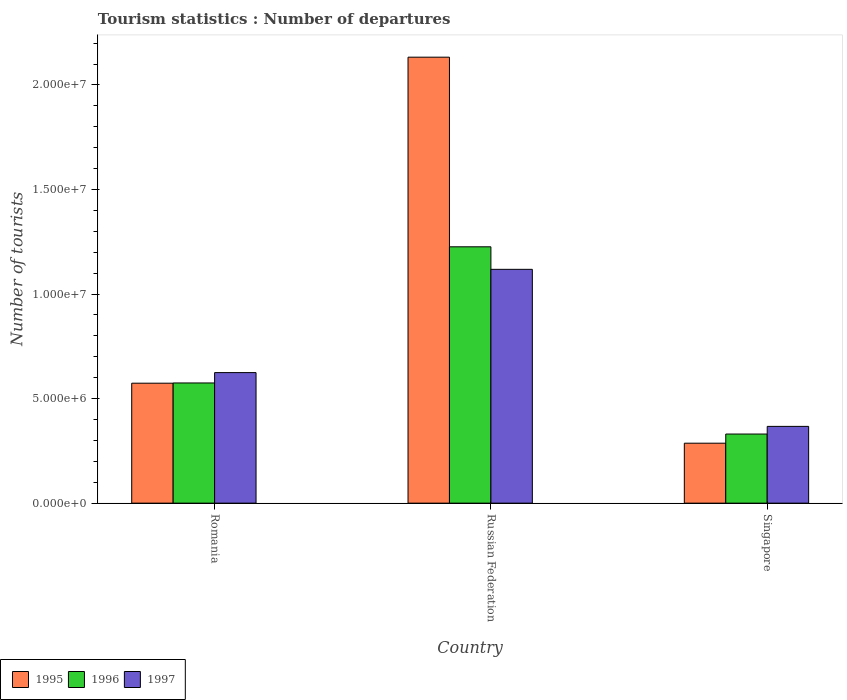Are the number of bars per tick equal to the number of legend labels?
Your response must be concise. Yes. How many bars are there on the 2nd tick from the left?
Keep it short and to the point. 3. What is the label of the 1st group of bars from the left?
Keep it short and to the point. Romania. In how many cases, is the number of bars for a given country not equal to the number of legend labels?
Make the answer very short. 0. What is the number of tourist departures in 1995 in Russian Federation?
Make the answer very short. 2.13e+07. Across all countries, what is the maximum number of tourist departures in 1997?
Offer a very short reply. 1.12e+07. Across all countries, what is the minimum number of tourist departures in 1997?
Give a very brief answer. 3.67e+06. In which country was the number of tourist departures in 1997 maximum?
Give a very brief answer. Russian Federation. In which country was the number of tourist departures in 1996 minimum?
Provide a succinct answer. Singapore. What is the total number of tourist departures in 1997 in the graph?
Make the answer very short. 2.11e+07. What is the difference between the number of tourist departures in 1997 in Romania and that in Singapore?
Give a very brief answer. 2.57e+06. What is the difference between the number of tourist departures in 1997 in Romania and the number of tourist departures in 1996 in Singapore?
Your response must be concise. 2.94e+06. What is the average number of tourist departures in 1996 per country?
Offer a very short reply. 7.10e+06. What is the difference between the number of tourist departures of/in 1996 and number of tourist departures of/in 1995 in Russian Federation?
Give a very brief answer. -9.07e+06. What is the ratio of the number of tourist departures in 1997 in Romania to that in Russian Federation?
Give a very brief answer. 0.56. What is the difference between the highest and the second highest number of tourist departures in 1997?
Make the answer very short. 4.94e+06. What is the difference between the highest and the lowest number of tourist departures in 1997?
Your response must be concise. 7.51e+06. In how many countries, is the number of tourist departures in 1997 greater than the average number of tourist departures in 1997 taken over all countries?
Offer a terse response. 1. Is the sum of the number of tourist departures in 1995 in Russian Federation and Singapore greater than the maximum number of tourist departures in 1997 across all countries?
Ensure brevity in your answer.  Yes. What does the 2nd bar from the right in Russian Federation represents?
Your answer should be very brief. 1996. What is the difference between two consecutive major ticks on the Y-axis?
Your response must be concise. 5.00e+06. Are the values on the major ticks of Y-axis written in scientific E-notation?
Provide a short and direct response. Yes. How many legend labels are there?
Keep it short and to the point. 3. What is the title of the graph?
Provide a succinct answer. Tourism statistics : Number of departures. What is the label or title of the Y-axis?
Provide a short and direct response. Number of tourists. What is the Number of tourists in 1995 in Romania?
Your response must be concise. 5.74e+06. What is the Number of tourists of 1996 in Romania?
Make the answer very short. 5.75e+06. What is the Number of tourists of 1997 in Romania?
Your answer should be compact. 6.24e+06. What is the Number of tourists of 1995 in Russian Federation?
Keep it short and to the point. 2.13e+07. What is the Number of tourists of 1996 in Russian Federation?
Offer a very short reply. 1.23e+07. What is the Number of tourists of 1997 in Russian Federation?
Your response must be concise. 1.12e+07. What is the Number of tourists of 1995 in Singapore?
Offer a very short reply. 2.87e+06. What is the Number of tourists of 1996 in Singapore?
Your response must be concise. 3.30e+06. What is the Number of tourists in 1997 in Singapore?
Your response must be concise. 3.67e+06. Across all countries, what is the maximum Number of tourists in 1995?
Provide a short and direct response. 2.13e+07. Across all countries, what is the maximum Number of tourists in 1996?
Offer a terse response. 1.23e+07. Across all countries, what is the maximum Number of tourists in 1997?
Ensure brevity in your answer.  1.12e+07. Across all countries, what is the minimum Number of tourists of 1995?
Ensure brevity in your answer.  2.87e+06. Across all countries, what is the minimum Number of tourists in 1996?
Give a very brief answer. 3.30e+06. Across all countries, what is the minimum Number of tourists of 1997?
Make the answer very short. 3.67e+06. What is the total Number of tourists of 1995 in the graph?
Offer a very short reply. 2.99e+07. What is the total Number of tourists in 1996 in the graph?
Your answer should be very brief. 2.13e+07. What is the total Number of tourists in 1997 in the graph?
Give a very brief answer. 2.11e+07. What is the difference between the Number of tourists in 1995 in Romania and that in Russian Federation?
Your answer should be very brief. -1.56e+07. What is the difference between the Number of tourists of 1996 in Romania and that in Russian Federation?
Provide a short and direct response. -6.51e+06. What is the difference between the Number of tourists in 1997 in Romania and that in Russian Federation?
Ensure brevity in your answer.  -4.94e+06. What is the difference between the Number of tourists in 1995 in Romania and that in Singapore?
Provide a succinct answer. 2.87e+06. What is the difference between the Number of tourists in 1996 in Romania and that in Singapore?
Make the answer very short. 2.44e+06. What is the difference between the Number of tourists of 1997 in Romania and that in Singapore?
Keep it short and to the point. 2.57e+06. What is the difference between the Number of tourists of 1995 in Russian Federation and that in Singapore?
Give a very brief answer. 1.85e+07. What is the difference between the Number of tourists in 1996 in Russian Federation and that in Singapore?
Make the answer very short. 8.96e+06. What is the difference between the Number of tourists of 1997 in Russian Federation and that in Singapore?
Make the answer very short. 7.51e+06. What is the difference between the Number of tourists in 1995 in Romania and the Number of tourists in 1996 in Russian Federation?
Provide a short and direct response. -6.52e+06. What is the difference between the Number of tourists in 1995 in Romania and the Number of tourists in 1997 in Russian Federation?
Your response must be concise. -5.44e+06. What is the difference between the Number of tourists of 1996 in Romania and the Number of tourists of 1997 in Russian Federation?
Offer a very short reply. -5.43e+06. What is the difference between the Number of tourists of 1995 in Romania and the Number of tourists of 1996 in Singapore?
Your answer should be compact. 2.43e+06. What is the difference between the Number of tourists of 1995 in Romania and the Number of tourists of 1997 in Singapore?
Provide a short and direct response. 2.07e+06. What is the difference between the Number of tourists in 1996 in Romania and the Number of tourists in 1997 in Singapore?
Your answer should be very brief. 2.08e+06. What is the difference between the Number of tourists of 1995 in Russian Federation and the Number of tourists of 1996 in Singapore?
Offer a very short reply. 1.80e+07. What is the difference between the Number of tourists of 1995 in Russian Federation and the Number of tourists of 1997 in Singapore?
Make the answer very short. 1.77e+07. What is the difference between the Number of tourists in 1996 in Russian Federation and the Number of tourists in 1997 in Singapore?
Provide a succinct answer. 8.59e+06. What is the average Number of tourists of 1995 per country?
Give a very brief answer. 9.98e+06. What is the average Number of tourists of 1996 per country?
Give a very brief answer. 7.10e+06. What is the average Number of tourists of 1997 per country?
Your response must be concise. 7.03e+06. What is the difference between the Number of tourists in 1995 and Number of tourists in 1996 in Romania?
Keep it short and to the point. -1.10e+04. What is the difference between the Number of tourists of 1995 and Number of tourists of 1997 in Romania?
Provide a short and direct response. -5.06e+05. What is the difference between the Number of tourists of 1996 and Number of tourists of 1997 in Romania?
Keep it short and to the point. -4.95e+05. What is the difference between the Number of tourists of 1995 and Number of tourists of 1996 in Russian Federation?
Keep it short and to the point. 9.07e+06. What is the difference between the Number of tourists of 1995 and Number of tourists of 1997 in Russian Federation?
Offer a terse response. 1.01e+07. What is the difference between the Number of tourists in 1996 and Number of tourists in 1997 in Russian Federation?
Your response must be concise. 1.08e+06. What is the difference between the Number of tourists of 1995 and Number of tourists of 1996 in Singapore?
Keep it short and to the point. -4.38e+05. What is the difference between the Number of tourists of 1995 and Number of tourists of 1997 in Singapore?
Provide a short and direct response. -8.04e+05. What is the difference between the Number of tourists in 1996 and Number of tourists in 1997 in Singapore?
Your answer should be compact. -3.66e+05. What is the ratio of the Number of tourists of 1995 in Romania to that in Russian Federation?
Your response must be concise. 0.27. What is the ratio of the Number of tourists of 1996 in Romania to that in Russian Federation?
Ensure brevity in your answer.  0.47. What is the ratio of the Number of tourists of 1997 in Romania to that in Russian Federation?
Offer a very short reply. 0.56. What is the ratio of the Number of tourists in 1995 in Romania to that in Singapore?
Provide a short and direct response. 2. What is the ratio of the Number of tourists of 1996 in Romania to that in Singapore?
Your response must be concise. 1.74. What is the ratio of the Number of tourists of 1997 in Romania to that in Singapore?
Offer a terse response. 1.7. What is the ratio of the Number of tourists in 1995 in Russian Federation to that in Singapore?
Ensure brevity in your answer.  7.44. What is the ratio of the Number of tourists in 1996 in Russian Federation to that in Singapore?
Your answer should be very brief. 3.71. What is the ratio of the Number of tourists of 1997 in Russian Federation to that in Singapore?
Make the answer very short. 3.05. What is the difference between the highest and the second highest Number of tourists in 1995?
Provide a short and direct response. 1.56e+07. What is the difference between the highest and the second highest Number of tourists of 1996?
Offer a very short reply. 6.51e+06. What is the difference between the highest and the second highest Number of tourists in 1997?
Give a very brief answer. 4.94e+06. What is the difference between the highest and the lowest Number of tourists of 1995?
Give a very brief answer. 1.85e+07. What is the difference between the highest and the lowest Number of tourists in 1996?
Your answer should be very brief. 8.96e+06. What is the difference between the highest and the lowest Number of tourists in 1997?
Give a very brief answer. 7.51e+06. 